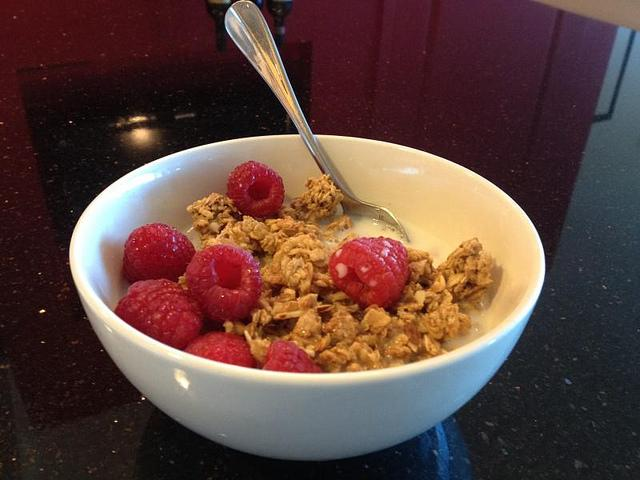Based on the reflections where is this bowl of cereal placed? Please explain your reasoning. kitchen. There is a reflection of an oven off of the countertop. 